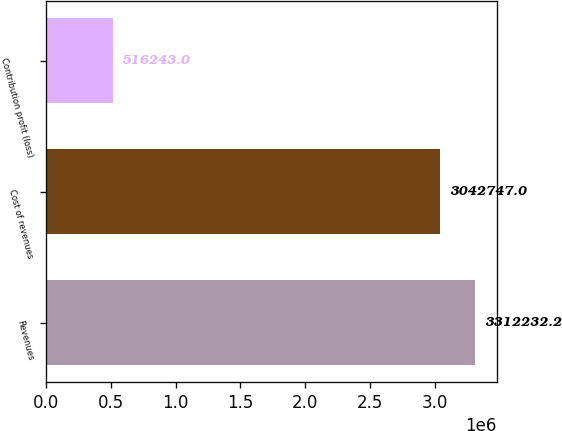Convert chart to OTSL. <chart><loc_0><loc_0><loc_500><loc_500><bar_chart><fcel>Revenues<fcel>Cost of revenues<fcel>Contribution profit (loss)<nl><fcel>3.31223e+06<fcel>3.04275e+06<fcel>516243<nl></chart> 